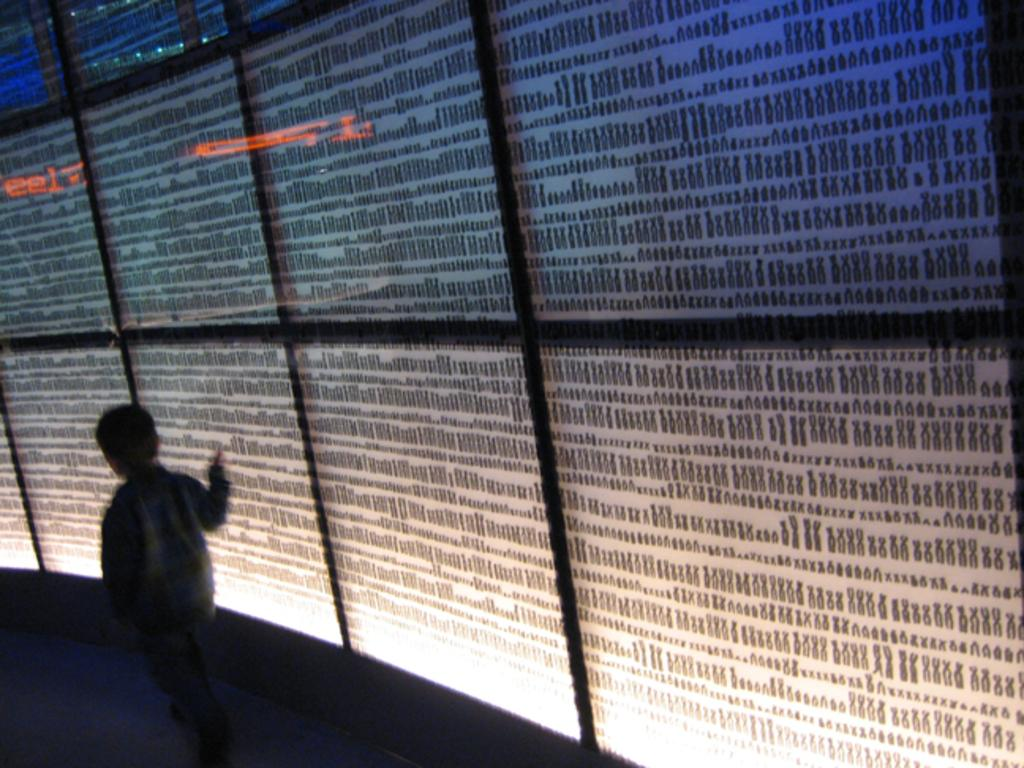What is the person in the image doing? The person is walking on the left side of the image. What can be seen on the right side of the image? There is a glass on the right side of the image. What is behind the glass in the image? There is a sheet behind the glass. How many rabbits are jumping over the glass in the image? There are no rabbits present in the image. What type of alarm is going off in the image? There is no alarm present in the image. 